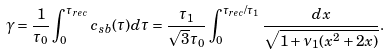Convert formula to latex. <formula><loc_0><loc_0><loc_500><loc_500>\gamma = \frac { 1 } { \tau _ { 0 } } \int _ { 0 } ^ { \tau _ { r e c } } c _ { s b } ( \tau ) d \tau = \frac { \tau _ { 1 } } { \sqrt { 3 } \tau _ { 0 } } \int _ { 0 } ^ { \tau _ { r e c } / \tau _ { 1 } } \frac { d x } { \sqrt { 1 + \nu _ { 1 } ( x ^ { 2 } + 2 x ) } } .</formula> 